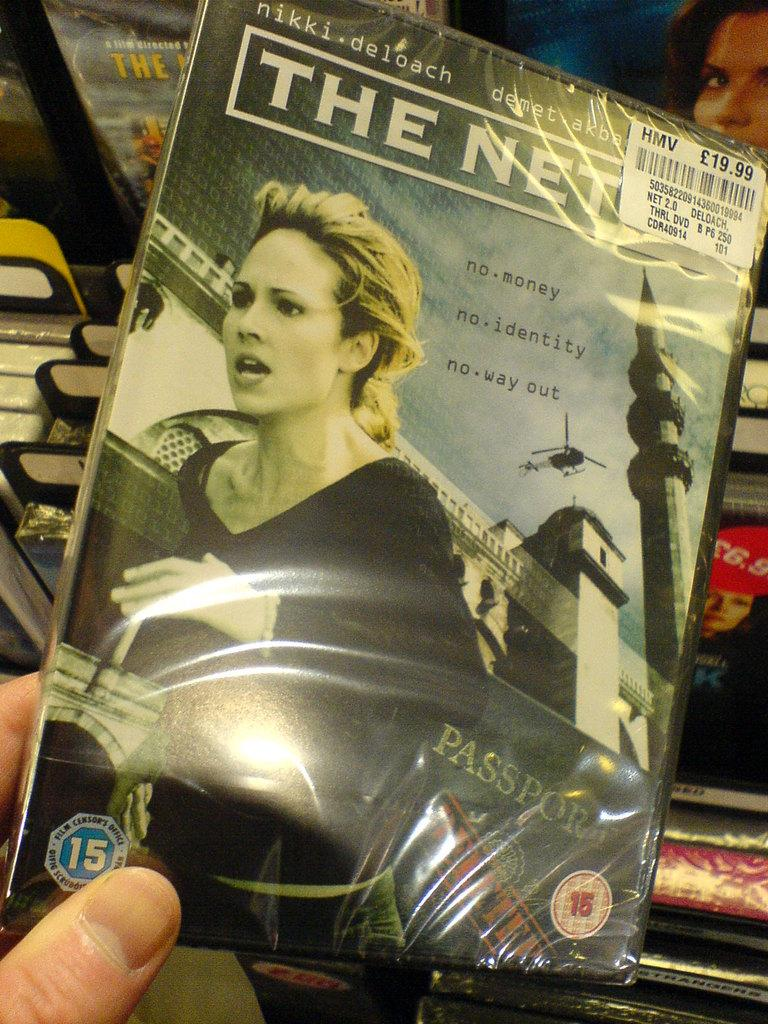<image>
Provide a brief description of the given image. The DVD package for the movie The Net 2.0. 